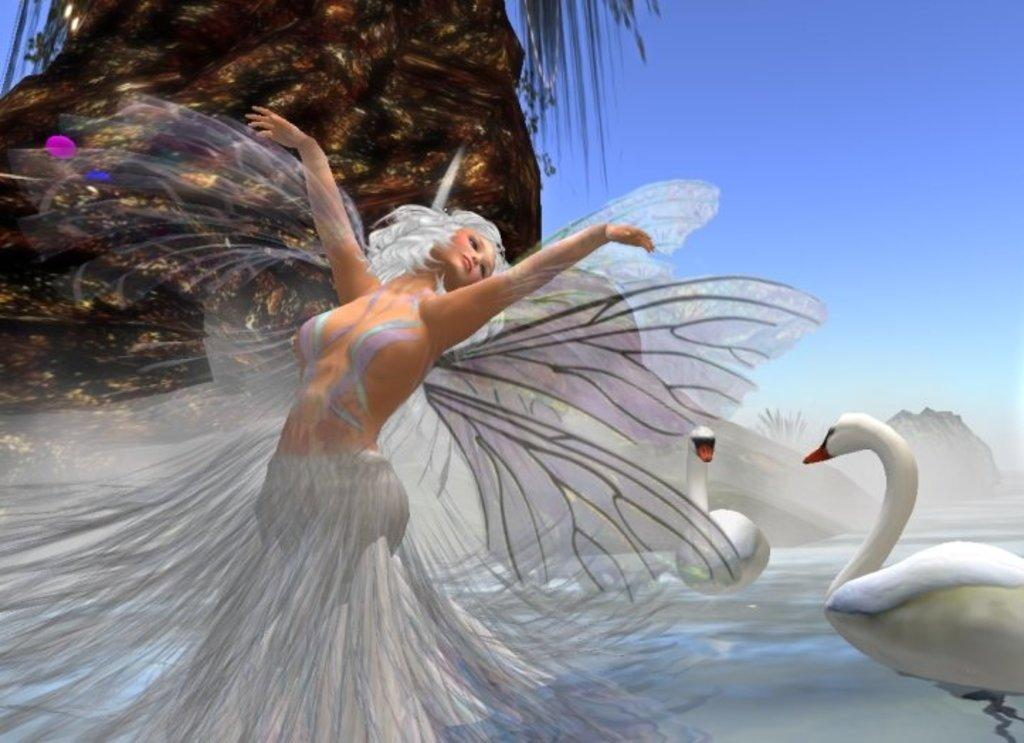How many birds can be seen in the image? There are two birds in the image. What is the person in the image depicted as having? The person in the image is depicted as having wings. What part of a tree is visible in the image? There is a tree trunk in the image. What type of vegetation is present in the image? There are leaves in the image. What can be seen above the birds and the person in the image? The sky is visible in the image. How many frogs are sitting on the twig in the image? There are no frogs or twigs present in the image. What type of office furniture can be seen in the image? There is no office furniture present in the image. 